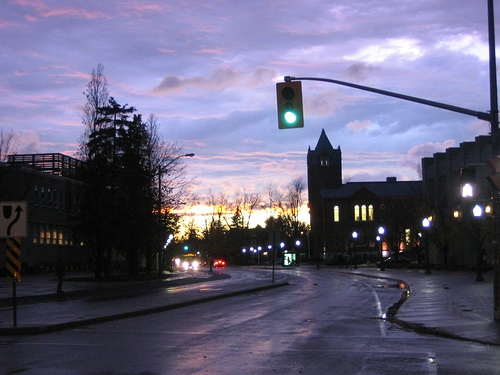Describe the objects in this image and their specific colors. I can see traffic light in gray, black, teal, and white tones, bus in gray, white, and lightpink tones, car in gray, white, and lightpink tones, people in black and gray tones, and car in gray, black, and darkgreen tones in this image. 